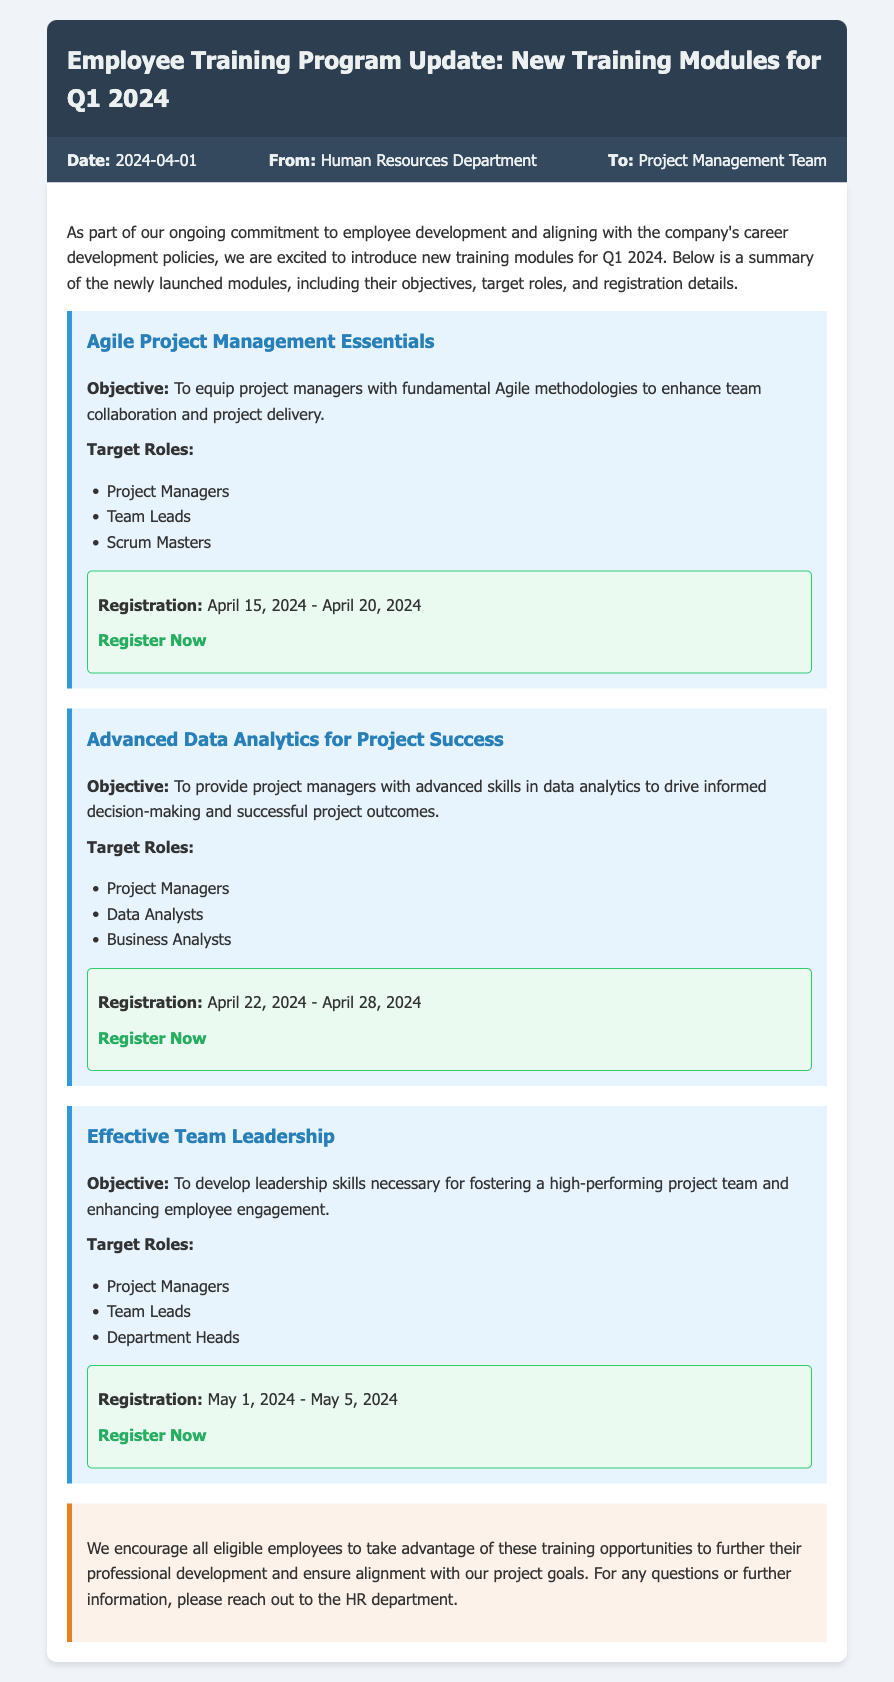What is the date of the memo? The date of the memo is stated prominently in the memo information section.
Answer: 2024-04-01 Who is the sender of the memo? The memo specifies the sender in the "From" section of the memo information.
Answer: Human Resources Department What is the target role for the Agile Project Management Essentials module? The memo lists the target roles under each module, including the Agile Project Management Essentials module.
Answer: Project Managers When is the registration period for the Advanced Data Analytics for Project Success module? The registration period is explicitly stated in the registration details for each module.
Answer: April 22, 2024 - April 28, 2024 What is the objective of the Effective Team Leadership module? The objective is provided under each module and clarifies the purpose of the training.
Answer: To develop leadership skills necessary for fostering a high-performing project team and enhancing employee engagement Which module has the registration link ending with "agile-essentials"? The registration link format helps identify the corresponding module by its URL.
Answer: Agile Project Management Essentials How many training modules are introduced in Q1 2024? The document summarizes three different training modules introduced during that period.
Answer: Three What is the main goal of the Employee Training Program Update? The opening paragraph highlights the purpose of the training program update.
Answer: To align with the company's career development policies 